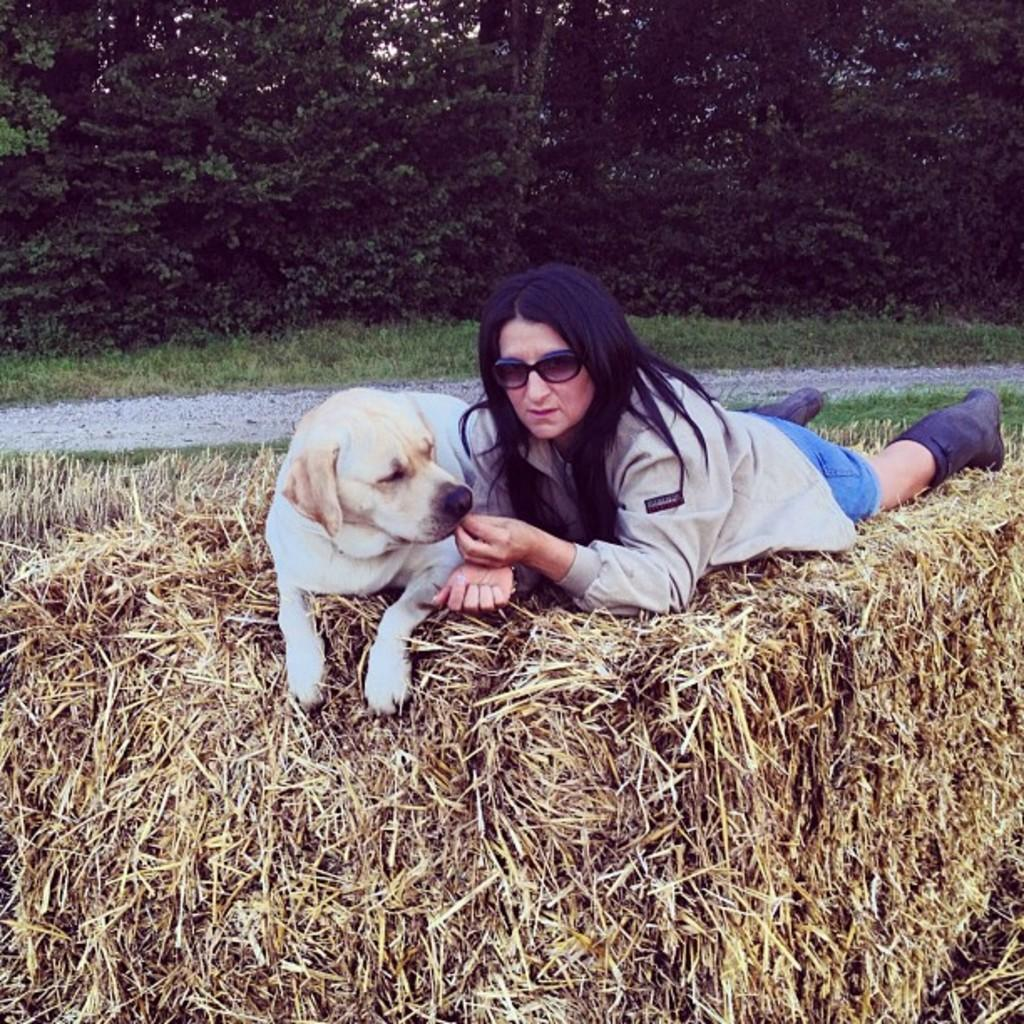What is the woman in the image doing? The woman is lying on the grass in the image. What is the woman wearing on her face? The woman is wearing spectacles. What other living creature is present in the image? There is a dog in the image. What can be seen in the distance in the image? There are trees and a road visible in the background of the image. What type of club does the woman use to hit the bottle in the image? There is no club or bottle present in the image. Can you tell me the age of the woman's grandfather in the image? There is no grandfather present in the image. 